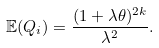<formula> <loc_0><loc_0><loc_500><loc_500>\mathbb { E } ( Q _ { i } ) = \frac { ( 1 + \lambda \theta ) ^ { 2 k } } { \lambda ^ { 2 } } .</formula> 